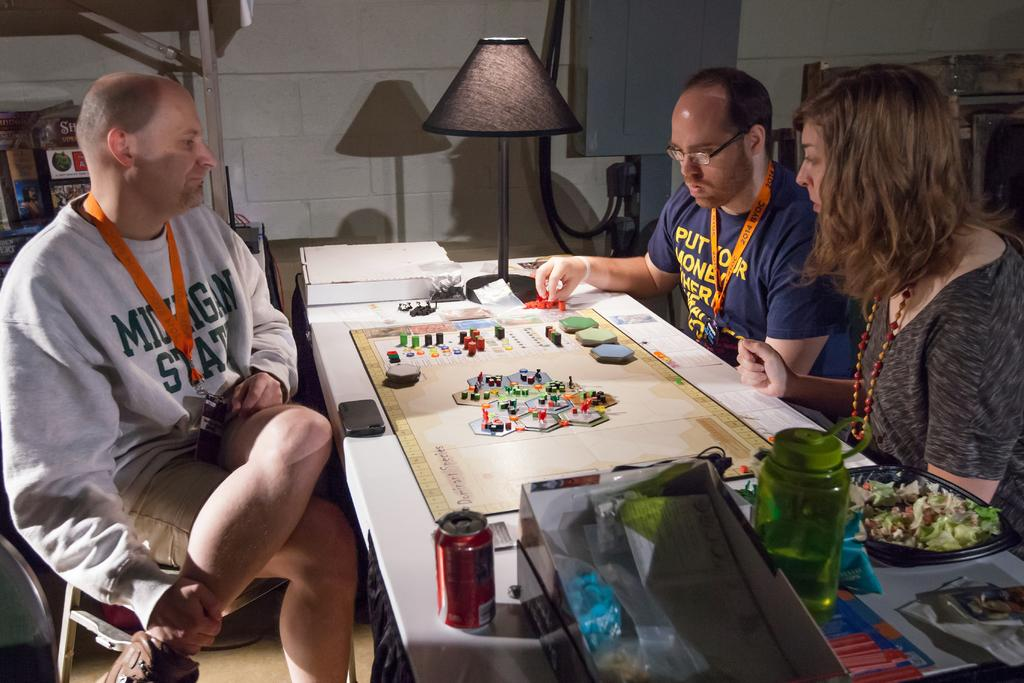How many people are present in the image? There are three people in the image. What are the people doing in the image? The people are seated on chairs and playing a game on a table. What can be seen on the table besides the game? There are water bottles and a salad bowl on the table. What type of underwear is the person on the left wearing in the image? There is no information about the underwear of the people in the image, as it is not visible or mentioned in the facts provided. 